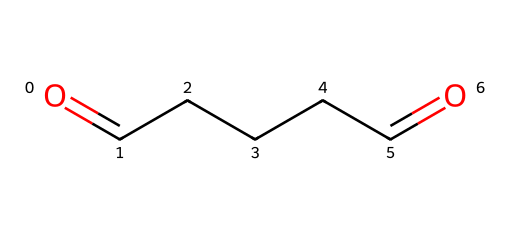How many carbon atoms are in glutaraldehyde? By examining the SMILES representation (O=CCCCC=O), you can count the number of carbon atoms represented by the letters "C". There are five carbon atoms in total.
Answer: 5 What functional groups are present in glutaraldehyde? The SMILES representation shows the carbon chains with two terminal aldehyde groups (indicated by the "O=" at both ends). This identifies glutaraldehyde as containing two aldehyde functional groups.
Answer: aldehyde What is the total number of oxygen atoms in glutaraldehyde? In the SMILES structure (O=CCCCC=O), there are two "O" characters indicating that there are two oxygen atoms present in the molecule.
Answer: 2 What is the relationship between the carbon atoms and the aldehyde groups in glutaraldehyde? The SMILES structure shows that the two aldehyde groups are positioned at each end of a five-carbon chain. Thus, the aldehyde groups are terminal functional groups connected to the first and last carbon atoms of the linear carbon chain.
Answer: terminal What type of chemical is glutaraldehyde classified as? Glutaraldehyde is a specific type of aldehyde due to its characteristic functional groups (aldehyde) at the ends of its carbon chain (as indicated by the presence of O= at either end of the molecule).
Answer: aldehyde How does glutaraldehyde's structure influence its use as a biocide? The presence of two aldehyde groups makes glutaraldehyde highly reactive with proteins and nucleic acids. This property allows it to effectively kill microorganisms, which is why it's used in biocides for applications such as cooling tower water treatment.
Answer: biocide 